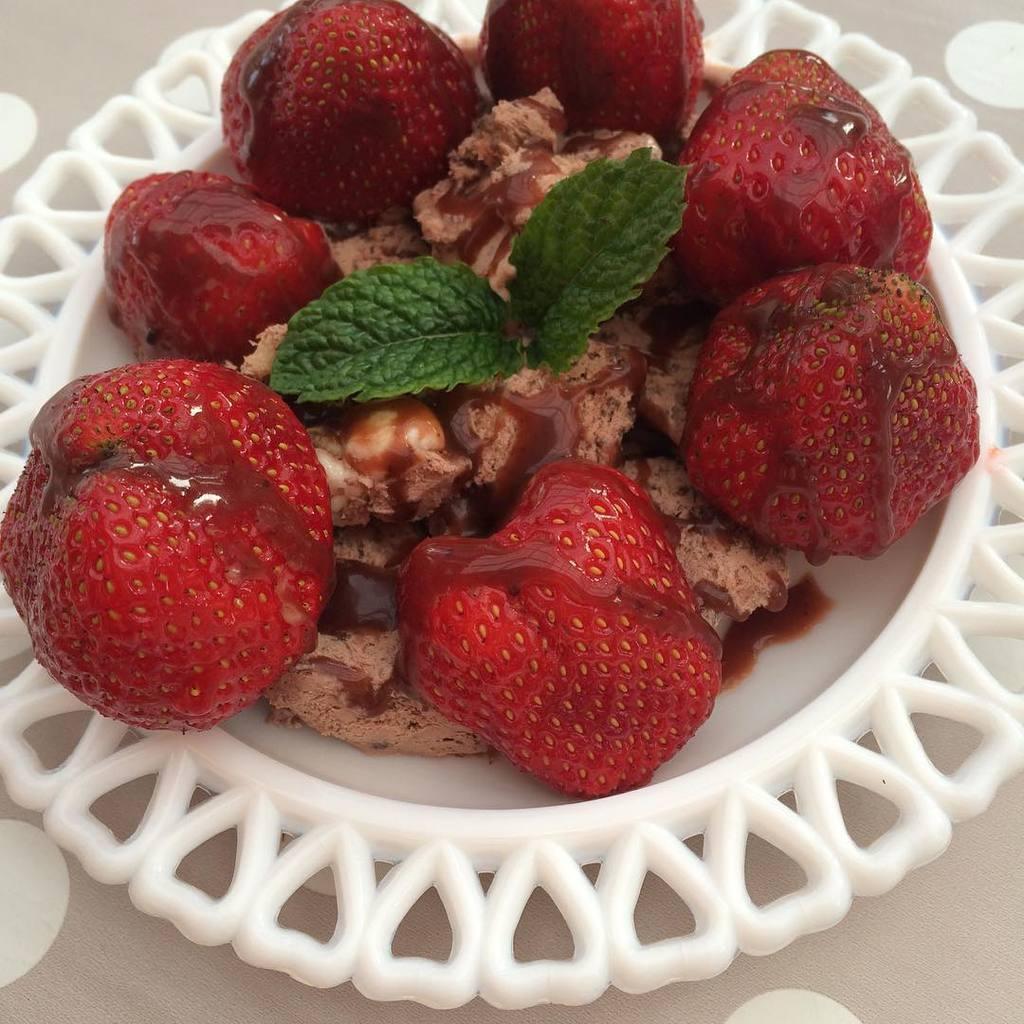Please provide a concise description of this image. In this image I can see the food in the white color plate. Food is in red, green and brown color. 